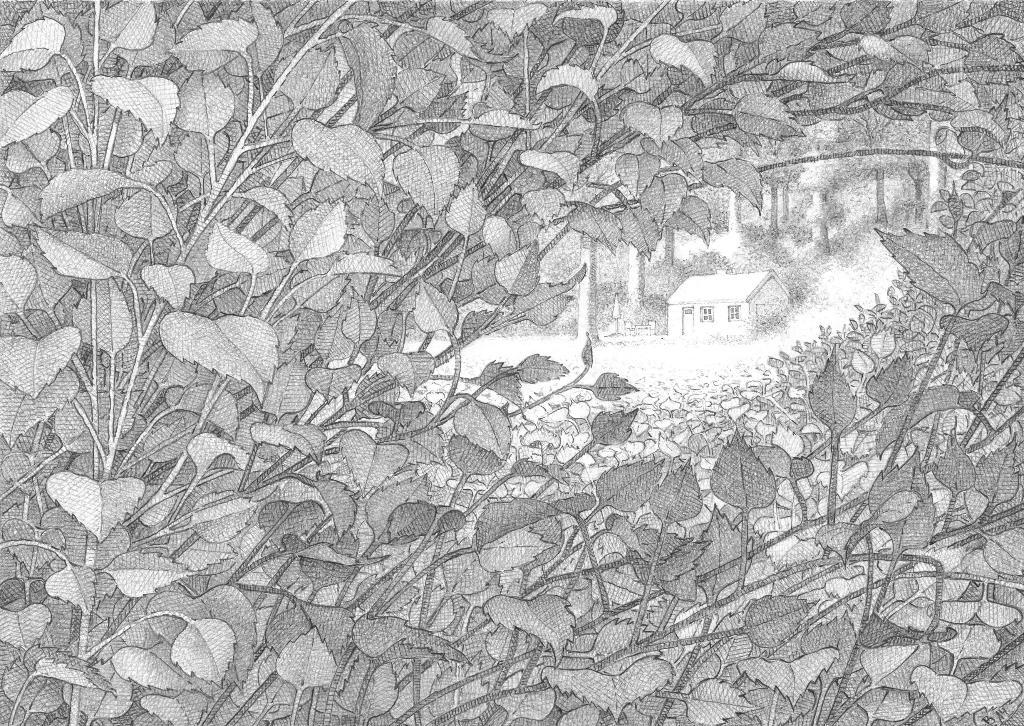What type of drawing is in the image? The image contains a sketch drawing. What is the subject of the sketch drawing? The sketch drawing depicts plants and a house. Can you describe the house in the sketch drawing? The house has a door and a window. What else can be seen near the house in the sketch drawing? There are plants and trees near the house in the sketch drawing. What type of clam is visible in the sketch drawing? There is no clam present in the sketch drawing; it depicts plants and a house. Can you tell me who approved the design of the house in the sketch drawing? The image does not provide information about who approved the design of the house, as it is a sketch drawing and not a real-life architectural plan. 